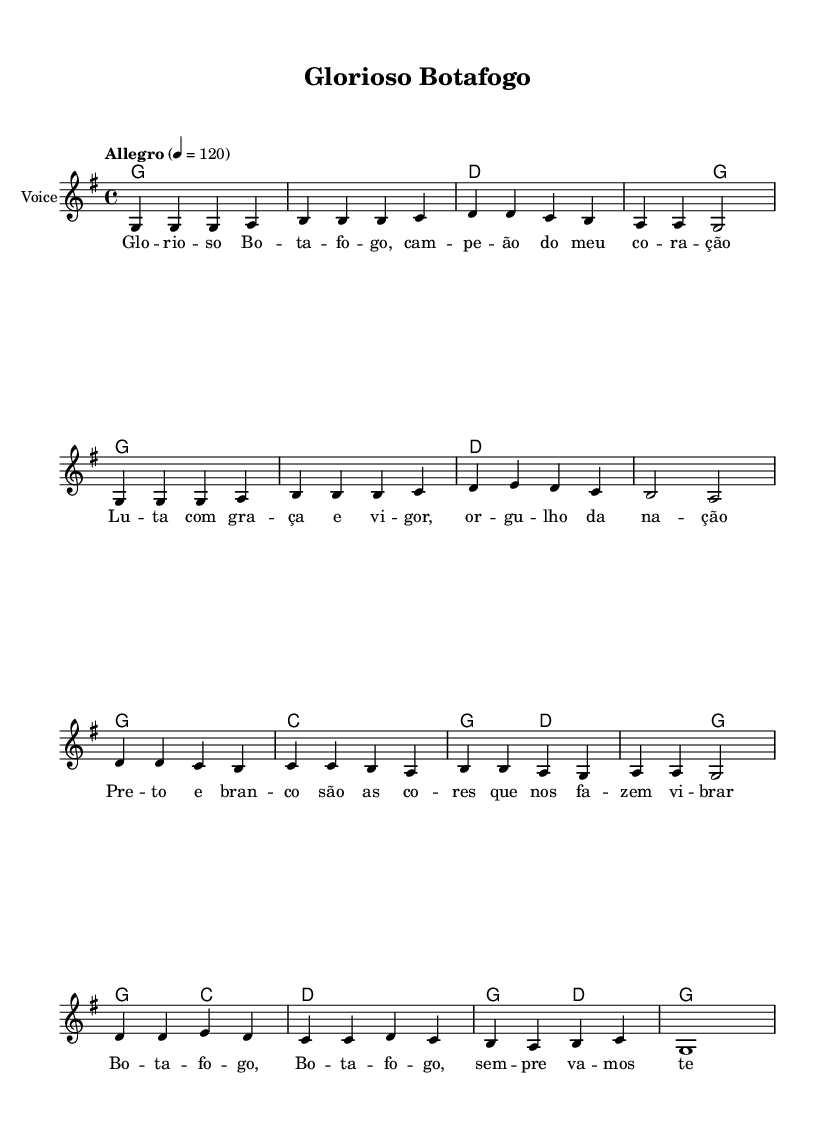What is the key signature of this music? The key signature is G major, which has one sharp, the F#. This is determined by looking at the key signature indicated at the beginning of the score.
Answer: G major What is the time signature of this music? The time signature is 4/4, which means there are four beats per measure. This is indicated by the notation seen at the beginning of the score.
Answer: 4/4 What is the tempo marking for this piece? The tempo marking is "Allegro," which typically indicates a fast and lively pace. This can be found near the beginning of the sheet music.
Answer: Allegro How many measures are in the melody section? The melody section has 16 measures, which can be counted by looking at the notation where each group is separated by vertical lines.
Answer: 16 What are the lyrics of the first line? The lyrics of the first line are "Glorioso Botafogo," which can be seen directly beneath the corresponding melody in the lyrics section.
Answer: Glorioso Botafogo What chord follows the first G chord in the harmonies? The chord that follows the first G chord is also G. This can be determined by observing the chord names listed under the melody.
Answer: G What is the last note in the melody? The last note in the melody is a G note. This is shown by the final note in the melody line at the end of the score.
Answer: G 